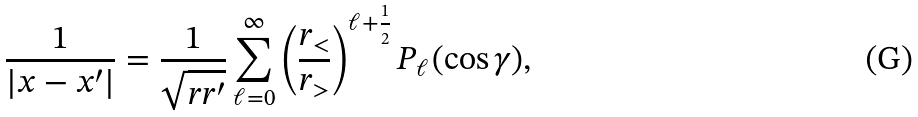<formula> <loc_0><loc_0><loc_500><loc_500>\frac { 1 } { | x - x ^ { \prime } | } = \frac { 1 } { \sqrt { r r ^ { \prime } } } \sum _ { \ell = 0 } ^ { \infty } \left ( \frac { r _ { < } } { r _ { > } } \right ) ^ { \ell + \frac { 1 } { 2 } } P _ { \ell } ( \cos \gamma ) ,</formula> 